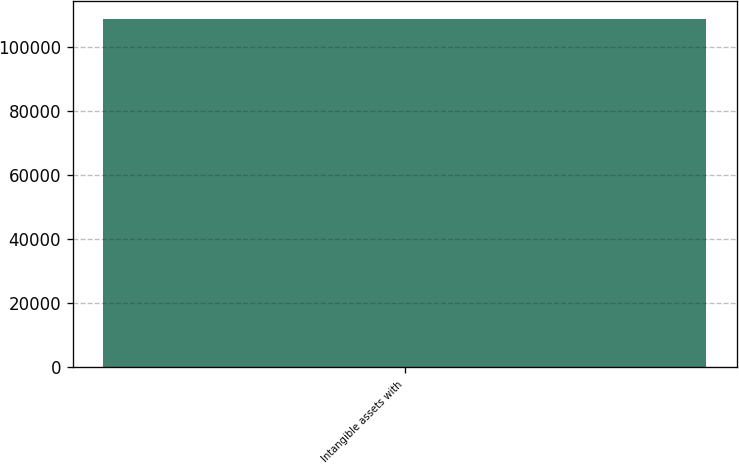Convert chart to OTSL. <chart><loc_0><loc_0><loc_500><loc_500><bar_chart><fcel>Intangible assets with<nl><fcel>108871<nl></chart> 